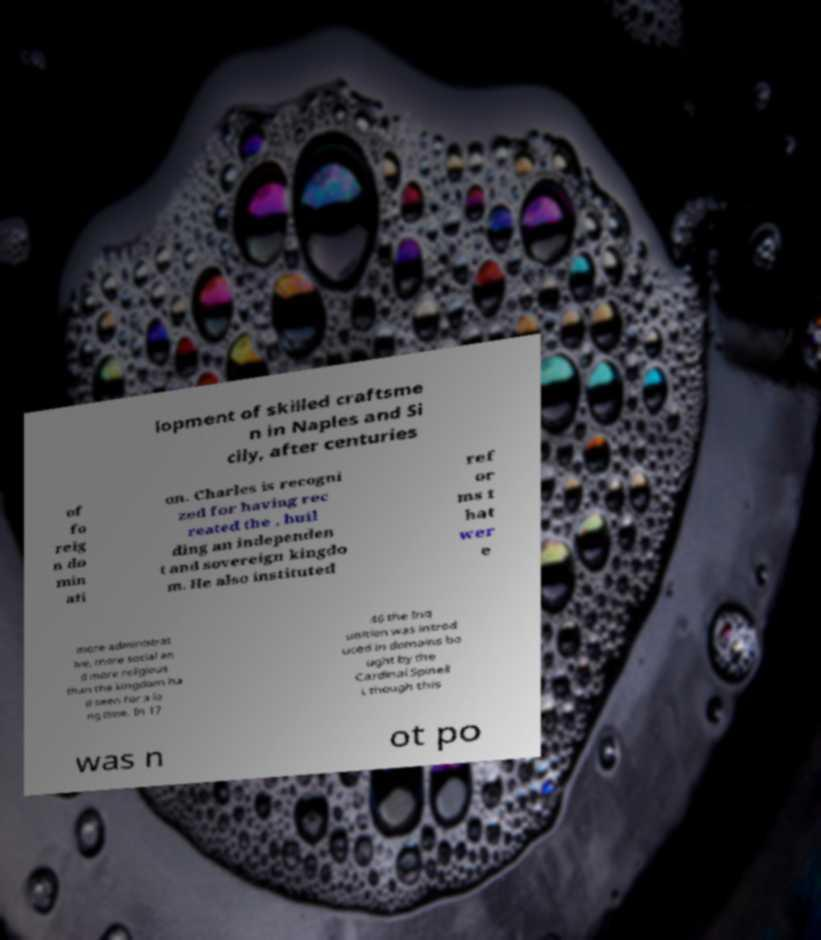What messages or text are displayed in this image? I need them in a readable, typed format. lopment of skilled craftsme n in Naples and Si cily, after centuries of fo reig n do min ati on. Charles is recogni zed for having rec reated the , buil ding an independen t and sovereign kingdo m. He also instituted ref or ms t hat wer e more administrat ive, more social an d more religious than the kingdom ha d seen for a lo ng time. In 17 46 the Inq uisition was introd uced in domains bo ught by the Cardinal Spinell i, though this was n ot po 